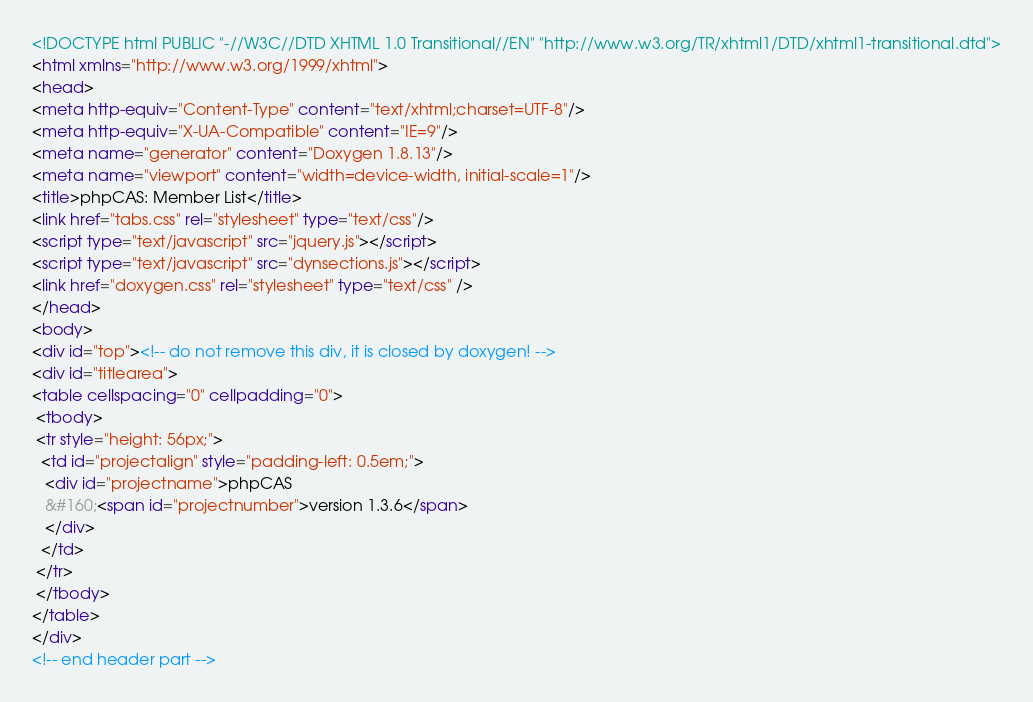<code> <loc_0><loc_0><loc_500><loc_500><_HTML_><!DOCTYPE html PUBLIC "-//W3C//DTD XHTML 1.0 Transitional//EN" "http://www.w3.org/TR/xhtml1/DTD/xhtml1-transitional.dtd">
<html xmlns="http://www.w3.org/1999/xhtml">
<head>
<meta http-equiv="Content-Type" content="text/xhtml;charset=UTF-8"/>
<meta http-equiv="X-UA-Compatible" content="IE=9"/>
<meta name="generator" content="Doxygen 1.8.13"/>
<meta name="viewport" content="width=device-width, initial-scale=1"/>
<title>phpCAS: Member List</title>
<link href="tabs.css" rel="stylesheet" type="text/css"/>
<script type="text/javascript" src="jquery.js"></script>
<script type="text/javascript" src="dynsections.js"></script>
<link href="doxygen.css" rel="stylesheet" type="text/css" />
</head>
<body>
<div id="top"><!-- do not remove this div, it is closed by doxygen! -->
<div id="titlearea">
<table cellspacing="0" cellpadding="0">
 <tbody>
 <tr style="height: 56px;">
  <td id="projectalign" style="padding-left: 0.5em;">
   <div id="projectname">phpCAS
   &#160;<span id="projectnumber">version 1.3.6</span>
   </div>
  </td>
 </tr>
 </tbody>
</table>
</div>
<!-- end header part --></code> 